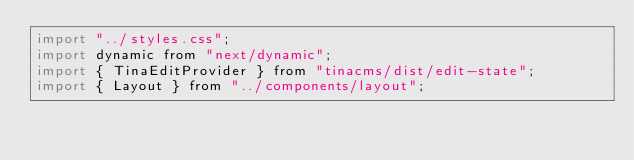<code> <loc_0><loc_0><loc_500><loc_500><_JavaScript_>import "../styles.css";
import dynamic from "next/dynamic";
import { TinaEditProvider } from "tinacms/dist/edit-state";
import { Layout } from "../components/layout";</code> 